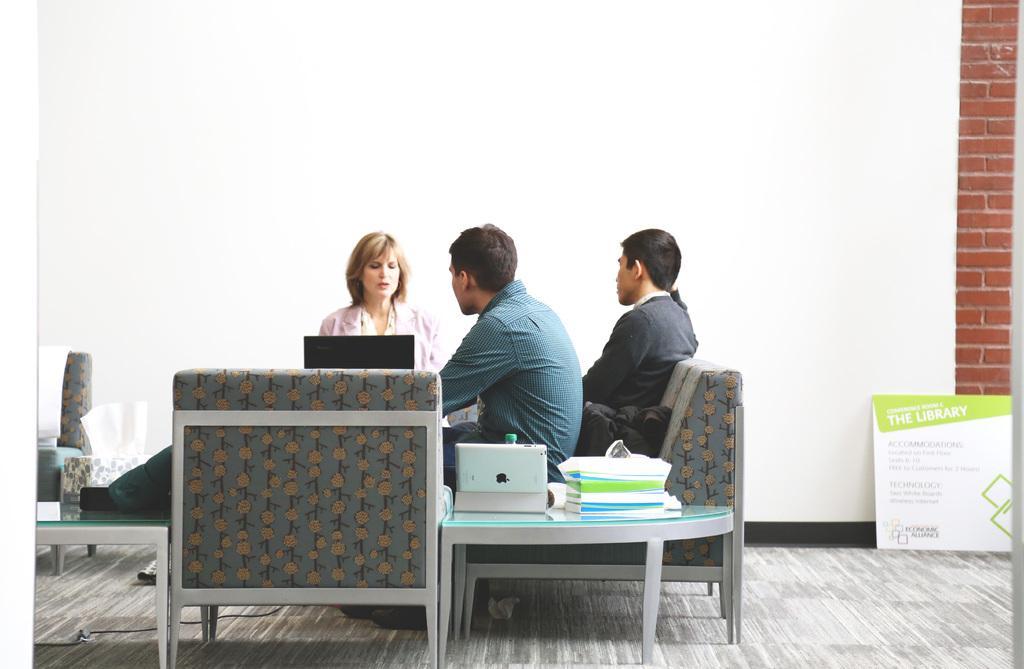In one or two sentences, can you explain what this image depicts? In the middle of the image, there are three persons sitting on the chair. Next to that a table is there on which books and bottle is kept. The background wall is white in color. And at the bottom, a brick wall is there. Below that a board is there. This image is taken inside a room. 